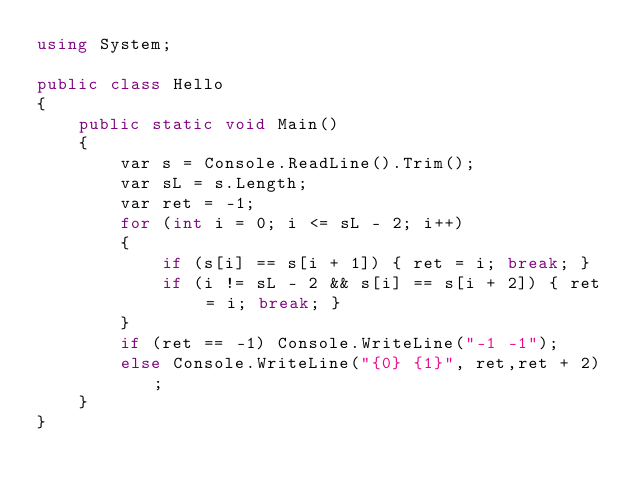<code> <loc_0><loc_0><loc_500><loc_500><_C#_>using System;

public class Hello
{
    public static void Main()
    {
        var s = Console.ReadLine().Trim();
        var sL = s.Length;
        var ret = -1;
        for (int i = 0; i <= sL - 2; i++)
        {
            if (s[i] == s[i + 1]) { ret = i; break; }
            if (i != sL - 2 && s[i] == s[i + 2]) { ret = i; break; }
        }
        if (ret == -1) Console.WriteLine("-1 -1");
        else Console.WriteLine("{0} {1}", ret,ret + 2);
    }
}</code> 